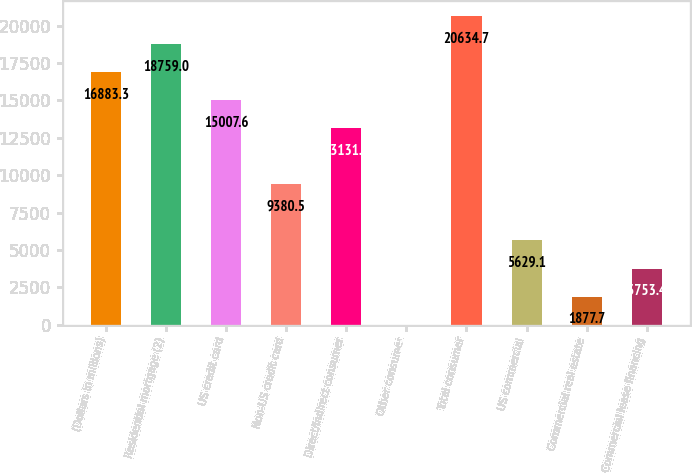Convert chart. <chart><loc_0><loc_0><loc_500><loc_500><bar_chart><fcel>(Dollars in millions)<fcel>Residential mortgage (2)<fcel>US credit card<fcel>Non-US credit card<fcel>Direct/Indirect consumer<fcel>Other consumer<fcel>Total consumer<fcel>US commercial<fcel>Commercial real estate<fcel>Commercial lease financing<nl><fcel>16883.3<fcel>18759<fcel>15007.6<fcel>9380.5<fcel>13131.9<fcel>2<fcel>20634.7<fcel>5629.1<fcel>1877.7<fcel>3753.4<nl></chart> 